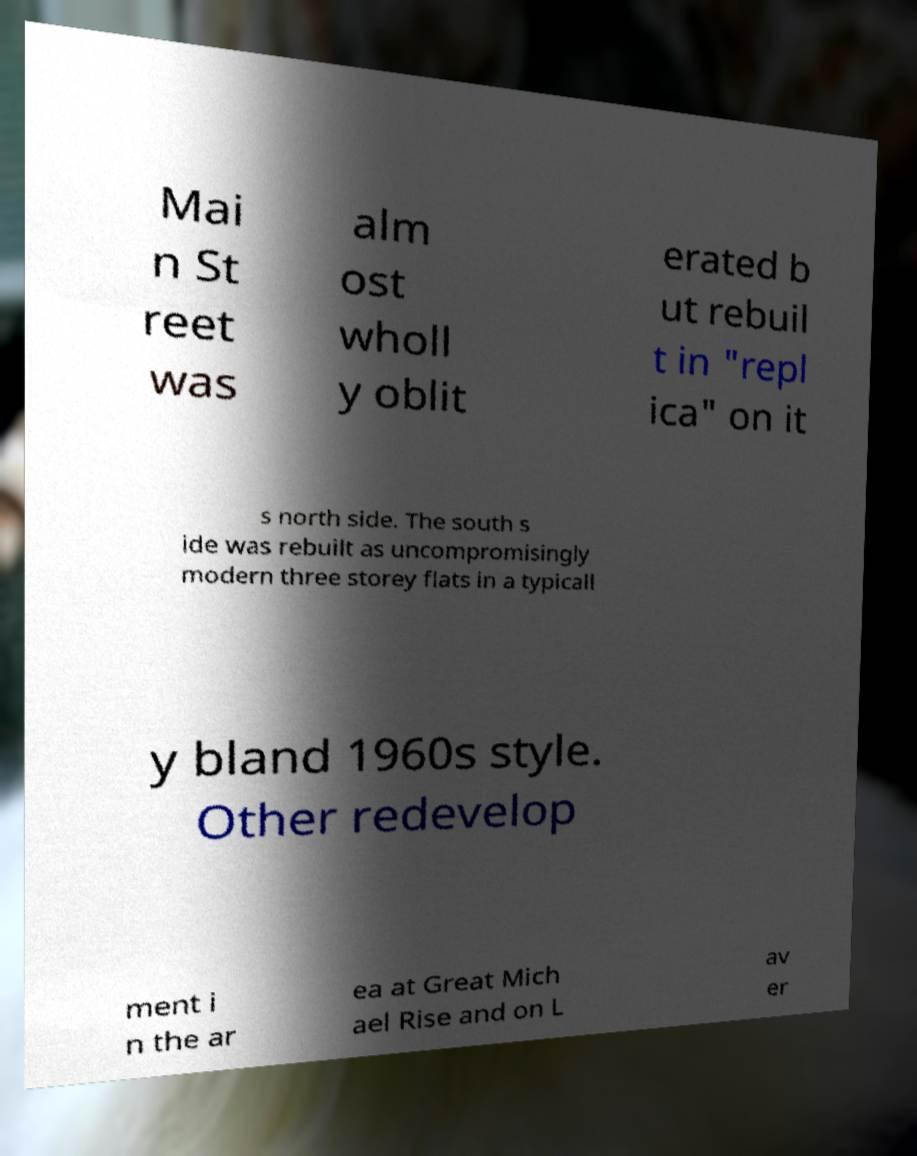Can you read and provide the text displayed in the image?This photo seems to have some interesting text. Can you extract and type it out for me? Mai n St reet was alm ost wholl y oblit erated b ut rebuil t in "repl ica" on it s north side. The south s ide was rebuilt as uncompromisingly modern three storey flats in a typicall y bland 1960s style. Other redevelop ment i n the ar ea at Great Mich ael Rise and on L av er 